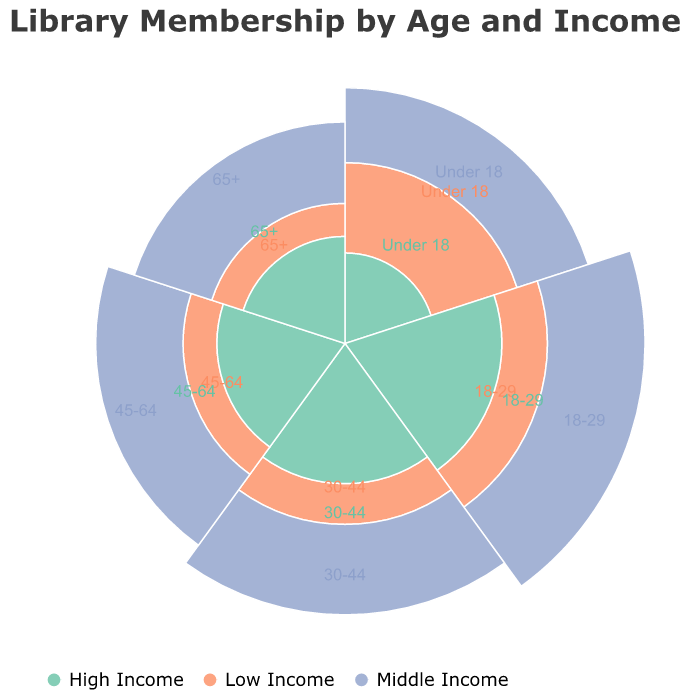What is the total membership count for the age group "18-29"? Sum the membership counts for all income levels within the "18-29" age group: 100 (Low Income) + 300 (Middle Income) + 150 (High Income). Therefore, 100 + 300 + 150 = 550.
Answer: 550 Which age group has the highest membership count for "High Income"? Compare the membership counts for "High Income" across all age groups: Under 18 (50), 18-29 (150), 30-44 (120), 45-64 (100), 65+ (70). The highest count is 150 in the "18-29" age group.
Answer: 18-29 How many more members are there in the "Under 18" age group with "Middle Income" compared to "High Income"? Subtract the membership count for "High Income" from the "Middle Income count" in the "Under 18" age group: 200 (Middle Income) - 50 (High Income) = 150.
Answer: 150 Which income level has the highest overall membership across all age groups? Sum the membership counts for each income level across all age groups: Low Income (150+100+80+60+50), Middle Income (200+300+250+220+180), High Income (50+150+120+100+70). The comparisons are Low Income (440), Middle Income (1150), High Income (490). "Middle Income" has the highest with 1150.
Answer: Middle Income In the "45-64" age group, how does the membership count for "Low Income" compare to "Middle Income"? Compare the counts for "Low Income" (60) and "Middle Income" (220) in the "45-64" age group. 60 is much less than 220.
Answer: Much less What is the combined membership count for those aged 30 and above? Sum the membership counts for all income levels in the age groups "30-44", "45-64", and "65+": (80+250+120) + (60+220+100) + (50+180+70). Therefore, 450 + 380 + 300 = 1130.
Answer: 1130 Which age group has the lowest membership count for "Low Income"? Compare the "Low Income" counts across all age groups: Under 18 (150), 18-29 (100), 30-44 (80), 45-64 (60), 65+ (50). The lowest count is 50 in the "65+" age group.
Answer: 65+ What is the percentage of "Middle Income" members in the "30-44" age group relative to its total membership? Calculate the total membership for "30-44" first (80+250+120=450), then find the proportion of "Middle Income" (250) to this total: (250/450) * 100% = 55.56%.
Answer: 55.56% Between "18-29" and "45-64" age groups, which has a higher membership count for "High Income"? Compare the membership counts for "High Income": 18-29 (150) vs 45-64 (100). The "18-29" age group has a higher count with 150.
Answer: 18-29 Does the "65+" age group have a higher total membership count compared to the "Under 18" age group? Calculate the total membership for each age group: "65+" (50+180+70 = 300), "Under 18" (150+200+50 = 400). Compare the sums; 300 < 400, so "65+" has a lower count.
Answer: No 